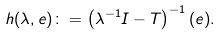<formula> <loc_0><loc_0><loc_500><loc_500>h ( \lambda , e ) \colon = \left ( \lambda ^ { - 1 } I - T \right ) ^ { - 1 } ( e ) .</formula> 